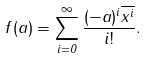Convert formula to latex. <formula><loc_0><loc_0><loc_500><loc_500>f ( a ) = \sum _ { i = 0 } ^ { \infty } \frac { ( - a ) ^ { i } \overline { x ^ { i } } } { i ! } .</formula> 